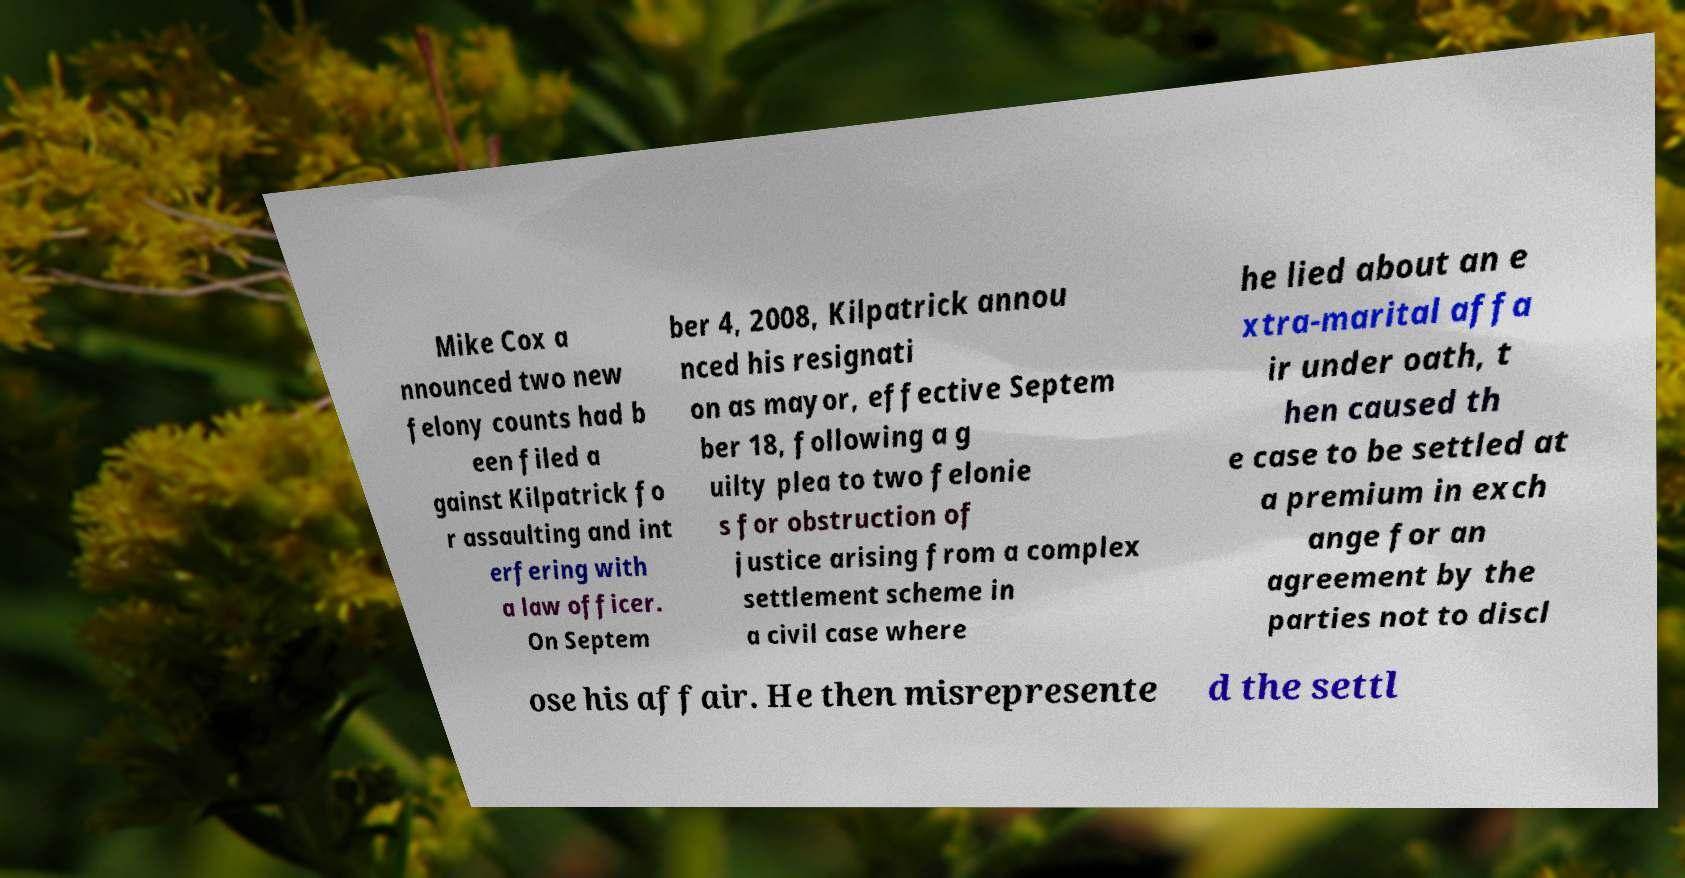For documentation purposes, I need the text within this image transcribed. Could you provide that? Mike Cox a nnounced two new felony counts had b een filed a gainst Kilpatrick fo r assaulting and int erfering with a law officer. On Septem ber 4, 2008, Kilpatrick annou nced his resignati on as mayor, effective Septem ber 18, following a g uilty plea to two felonie s for obstruction of justice arising from a complex settlement scheme in a civil case where he lied about an e xtra-marital affa ir under oath, t hen caused th e case to be settled at a premium in exch ange for an agreement by the parties not to discl ose his affair. He then misrepresente d the settl 